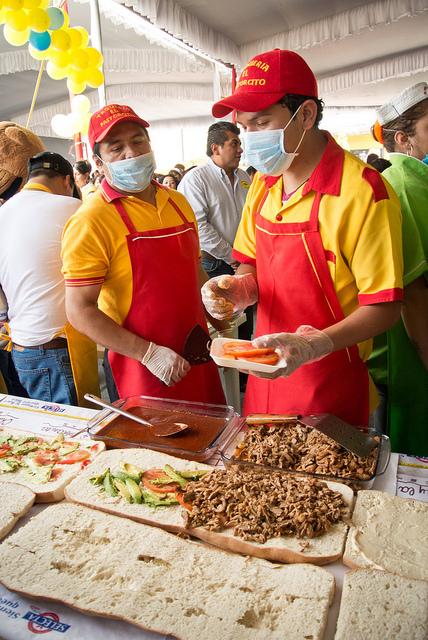Why are the people wearing gloves?
Give a very brief answer. Yes. Are the workers wearing masks?
Short answer required. Yes. Is the man holding tomato?
Be succinct. Yes. 